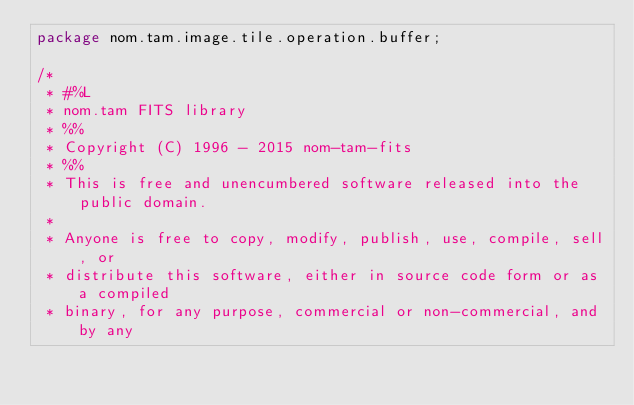Convert code to text. <code><loc_0><loc_0><loc_500><loc_500><_Java_>package nom.tam.image.tile.operation.buffer;

/*
 * #%L
 * nom.tam FITS library
 * %%
 * Copyright (C) 1996 - 2015 nom-tam-fits
 * %%
 * This is free and unencumbered software released into the public domain.
 * 
 * Anyone is free to copy, modify, publish, use, compile, sell, or
 * distribute this software, either in source code form or as a compiled
 * binary, for any purpose, commercial or non-commercial, and by any</code> 